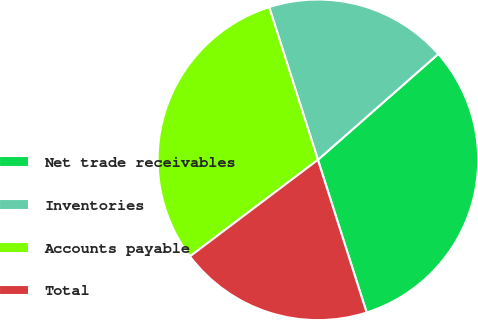Convert chart. <chart><loc_0><loc_0><loc_500><loc_500><pie_chart><fcel>Net trade receivables<fcel>Inventories<fcel>Accounts payable<fcel>Total<nl><fcel>31.56%<fcel>18.44%<fcel>30.37%<fcel>19.63%<nl></chart> 